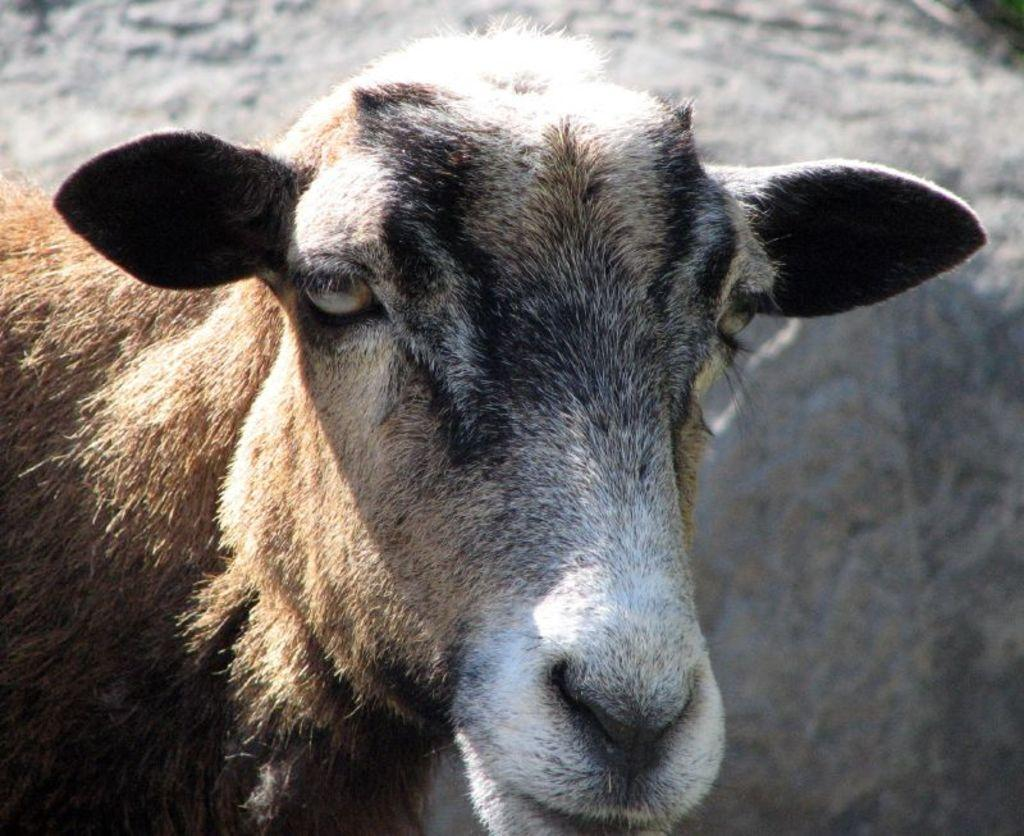What type of living creature is present in the image? There is an animal in the image. What can be seen in the background of the image? There is a wall in the background of the image. How many giants are visible in the image? There are no giants present in the image. What type of jellyfish can be seen swimming near the animal in the image? There is no jellyfish present in the image. 